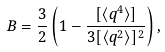Convert formula to latex. <formula><loc_0><loc_0><loc_500><loc_500>B = \frac { 3 } { 2 } \left ( 1 - \frac { [ \langle q ^ { 4 } \rangle ] } { 3 [ \langle q ^ { 2 } \rangle ] ^ { 2 } } \right ) ,</formula> 